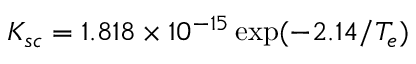Convert formula to latex. <formula><loc_0><loc_0><loc_500><loc_500>K _ { s c } = 1 . 8 1 8 \times 1 0 ^ { - 1 5 } \exp ( { - 2 . 1 4 / T _ { e } } )</formula> 